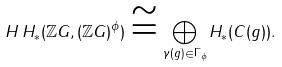Convert formula to latex. <formula><loc_0><loc_0><loc_500><loc_500>H \, H _ { \ast } ( \mathbb { Z } G , ( \mathbb { Z } G ) ^ { \phi } ) \cong \bigoplus _ { \gamma ( g ) \in \Gamma _ { \phi } } H _ { \ast } ( C ( g ) ) .</formula> 